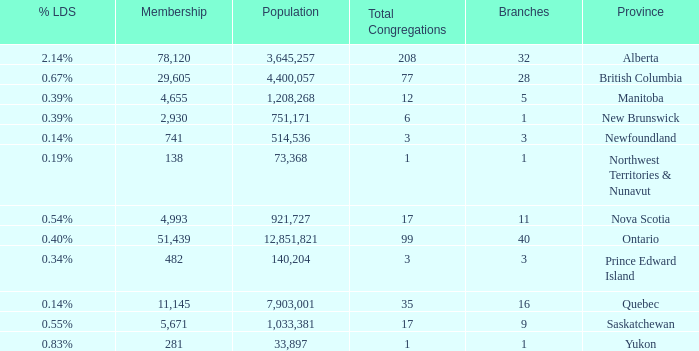What's the fewest number of branches with more than 1 total congregations, a population of 1,033,381, and a membership smaller than 5,671? None. 